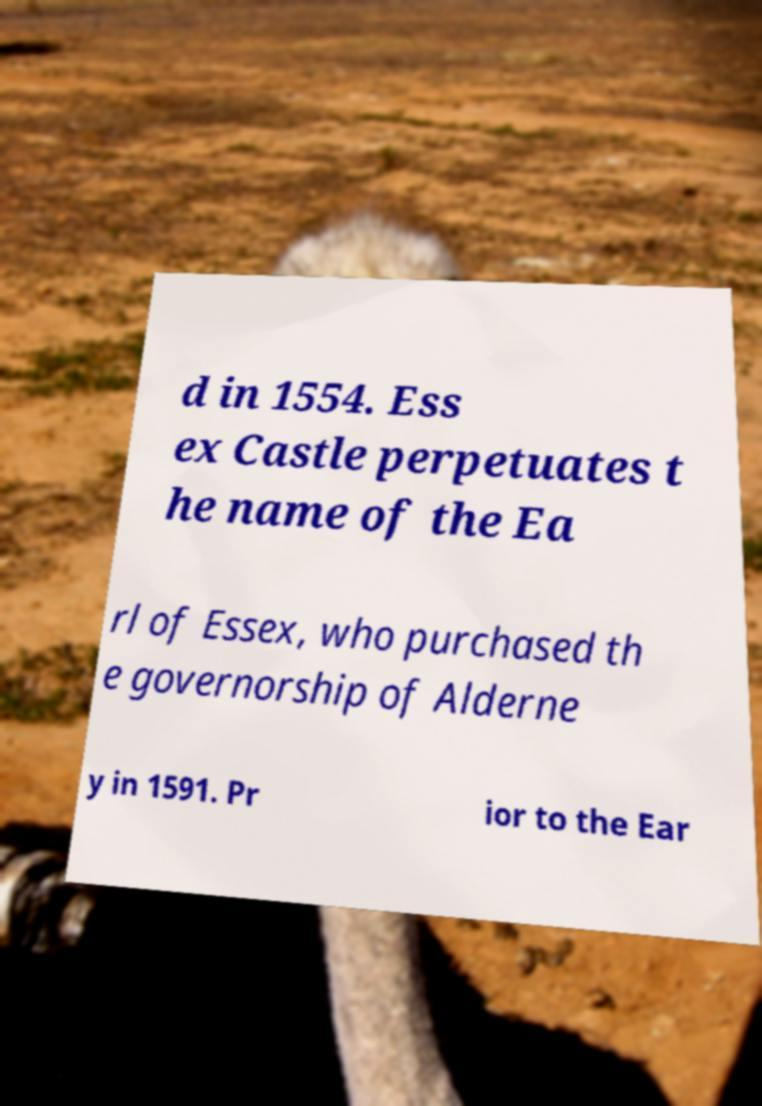Could you assist in decoding the text presented in this image and type it out clearly? d in 1554. Ess ex Castle perpetuates t he name of the Ea rl of Essex, who purchased th e governorship of Alderne y in 1591. Pr ior to the Ear 